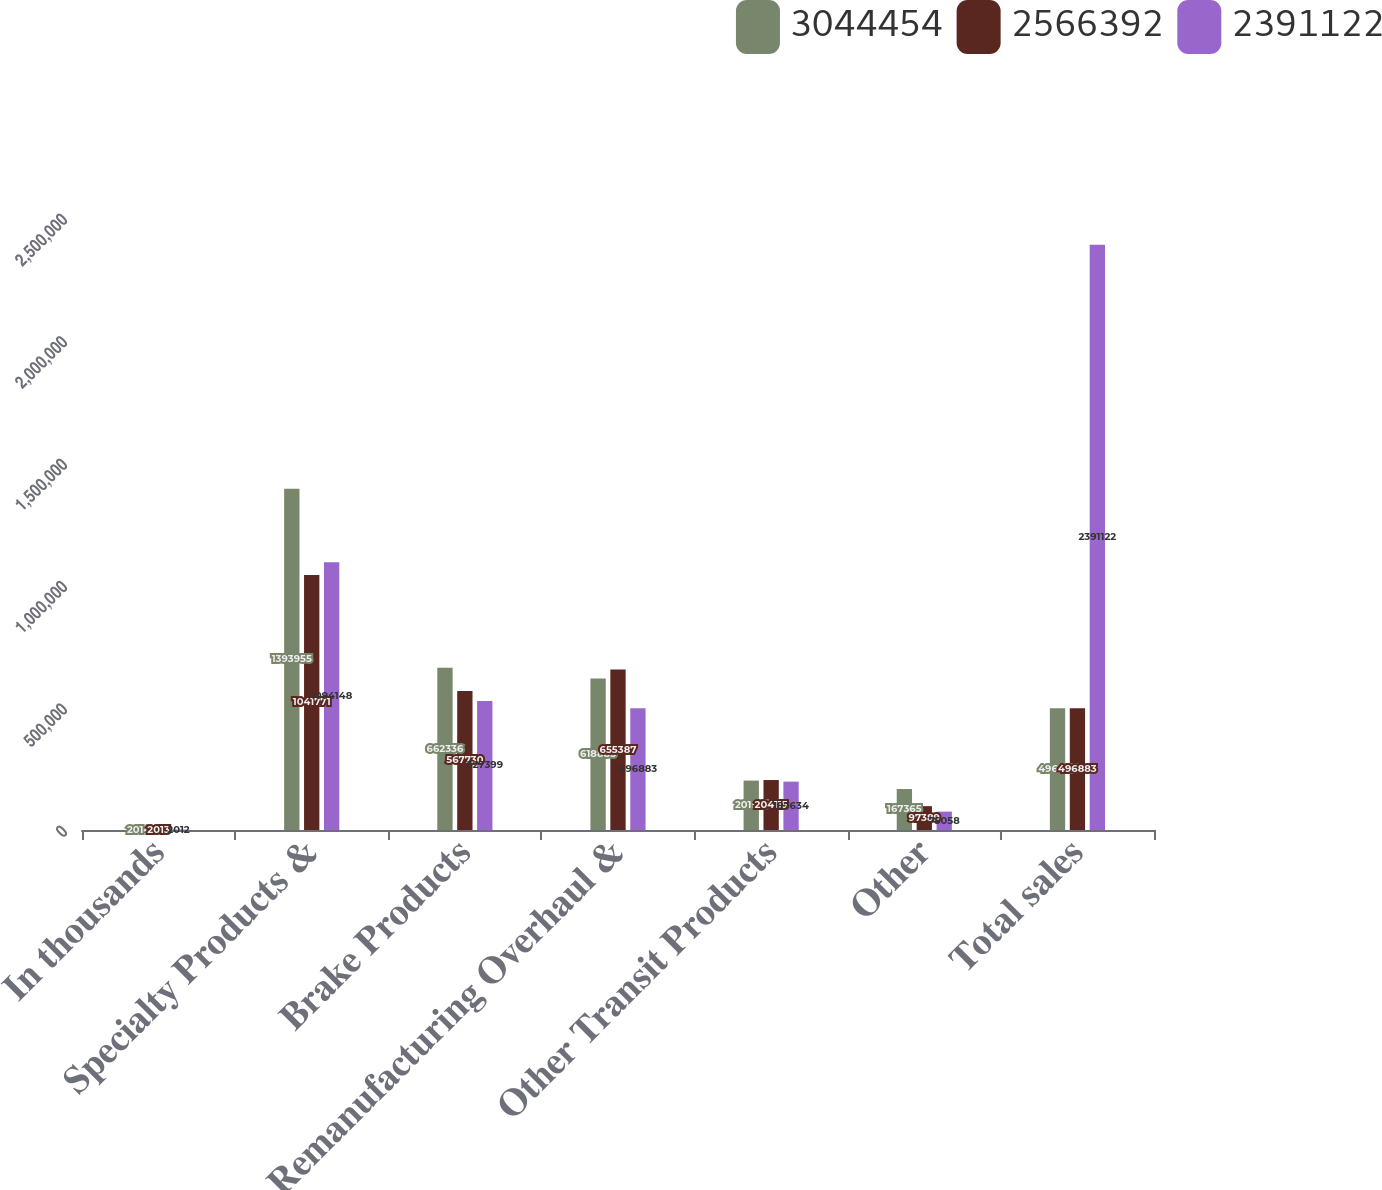Convert chart to OTSL. <chart><loc_0><loc_0><loc_500><loc_500><stacked_bar_chart><ecel><fcel>In thousands<fcel>Specialty Products &<fcel>Brake Products<fcel>Remanufacturing Overhaul &<fcel>Other Transit Products<fcel>Other<fcel>Total sales<nl><fcel>3.04445e+06<fcel>2014<fcel>1.39396e+06<fcel>662336<fcel>618885<fcel>201913<fcel>167365<fcel>496883<nl><fcel>2.56639e+06<fcel>2013<fcel>1.04177e+06<fcel>567730<fcel>655387<fcel>204115<fcel>97389<fcel>496883<nl><fcel>2.39112e+06<fcel>2012<fcel>1.09415e+06<fcel>527399<fcel>496883<fcel>197634<fcel>75058<fcel>2.39112e+06<nl></chart> 